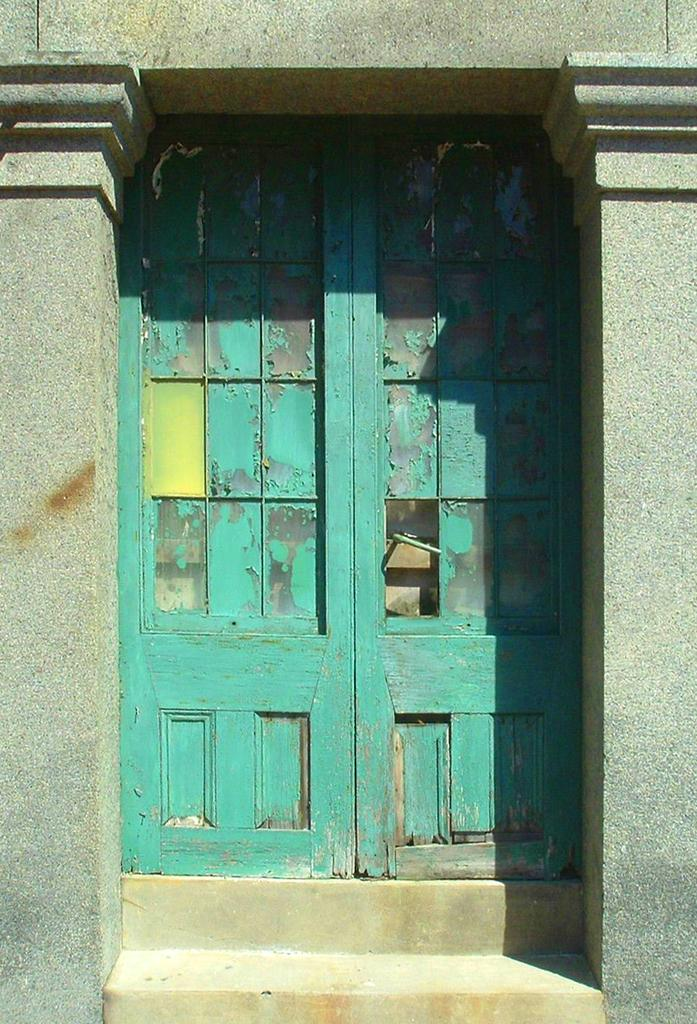What type of architectural feature can be seen in the image? There are doors, steps, and pillars in the image. Can you describe the steps in the image? The steps are a series of connected platforms that allow for elevation changes. What purpose do the pillars serve in the image? The pillars provide support for the structure and can also serve as decorative elements. What type of cushion is placed on the street in the image? There is no cushion or street present in the image; it only features doors, steps, and pillars. 